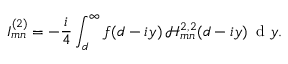Convert formula to latex. <formula><loc_0><loc_0><loc_500><loc_500>I _ { m n } ^ { ( 2 ) } = - \frac { i } { 4 } \int _ { d } ^ { \infty } f ( d - i y ) \, \mathcal { H } _ { m n } ^ { 2 , 2 } ( d - i y ) \, d y .</formula> 